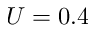<formula> <loc_0><loc_0><loc_500><loc_500>U = 0 . 4</formula> 